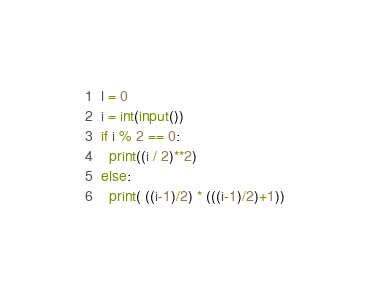<code> <loc_0><loc_0><loc_500><loc_500><_Python_>l = 0
i = int(input())
if i % 2 == 0:
  print((i / 2)**2)
else:
  print( ((i-1)/2) * (((i-1)/2)+1))</code> 